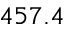<formula> <loc_0><loc_0><loc_500><loc_500>4 5 7 . 4</formula> 